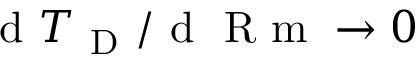<formula> <loc_0><loc_0><loc_500><loc_500>d { T _ { D } } / d R m \rightarrow 0</formula> 